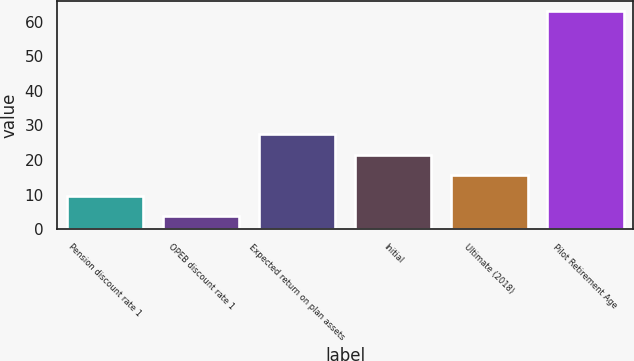Convert chart to OTSL. <chart><loc_0><loc_0><loc_500><loc_500><bar_chart><fcel>Pension discount rate 1<fcel>OPEB discount rate 1<fcel>Expected return on plan assets<fcel>Initial<fcel>Ultimate (2018)<fcel>Pilot Retirement Age<nl><fcel>9.72<fcel>3.8<fcel>27.48<fcel>21.56<fcel>15.64<fcel>63<nl></chart> 